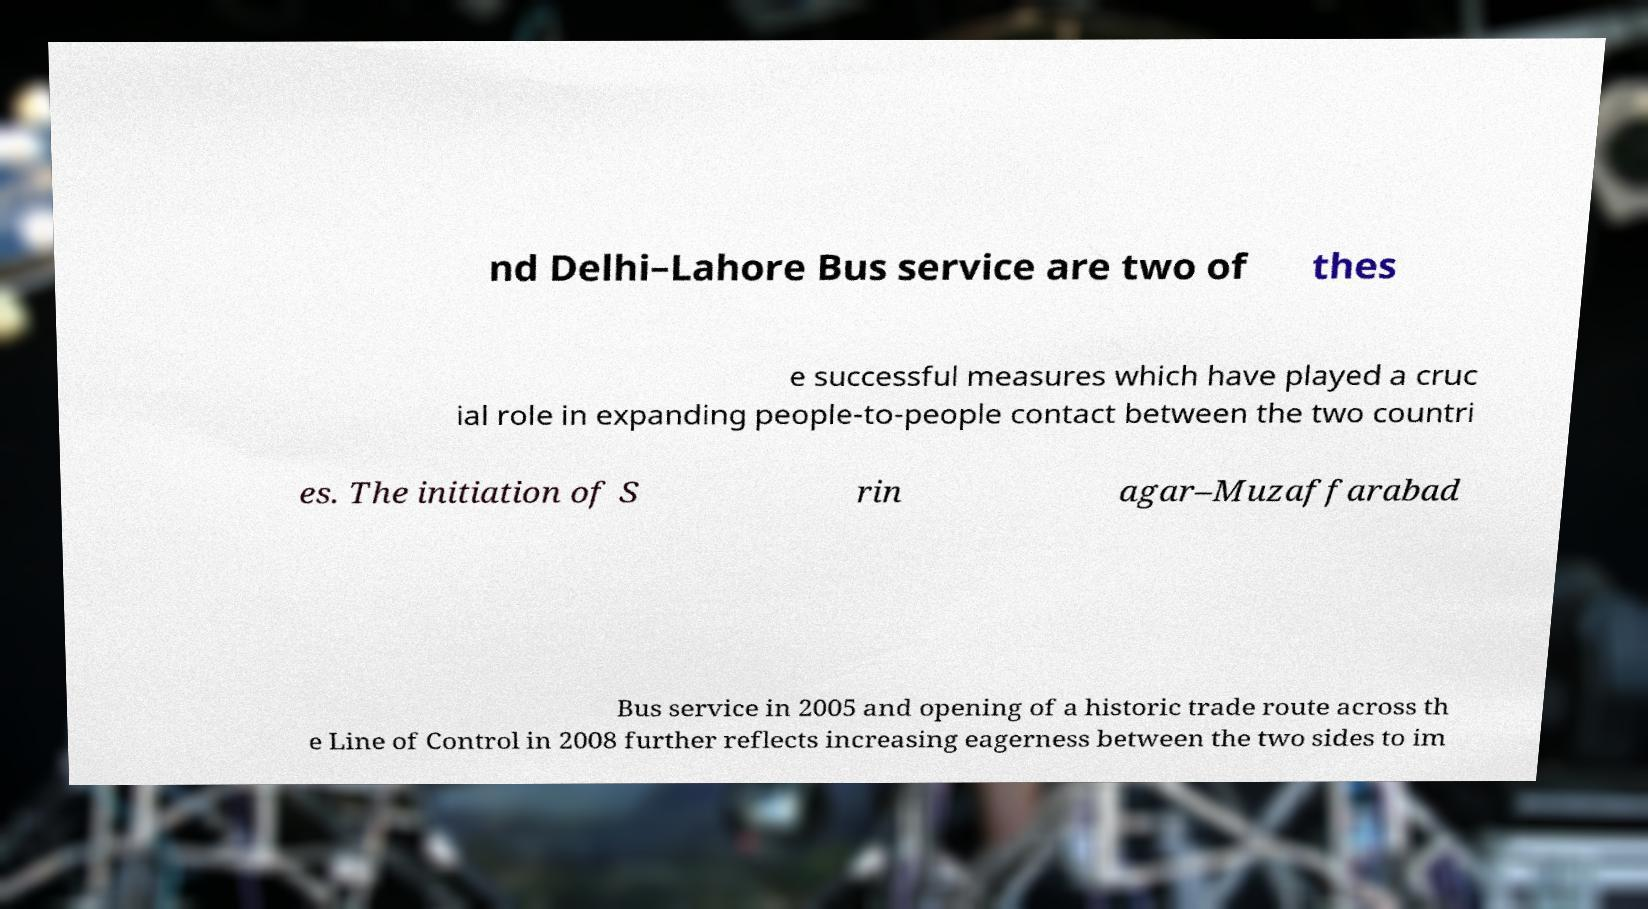There's text embedded in this image that I need extracted. Can you transcribe it verbatim? nd Delhi–Lahore Bus service are two of thes e successful measures which have played a cruc ial role in expanding people-to-people contact between the two countri es. The initiation of S rin agar–Muzaffarabad Bus service in 2005 and opening of a historic trade route across th e Line of Control in 2008 further reflects increasing eagerness between the two sides to im 